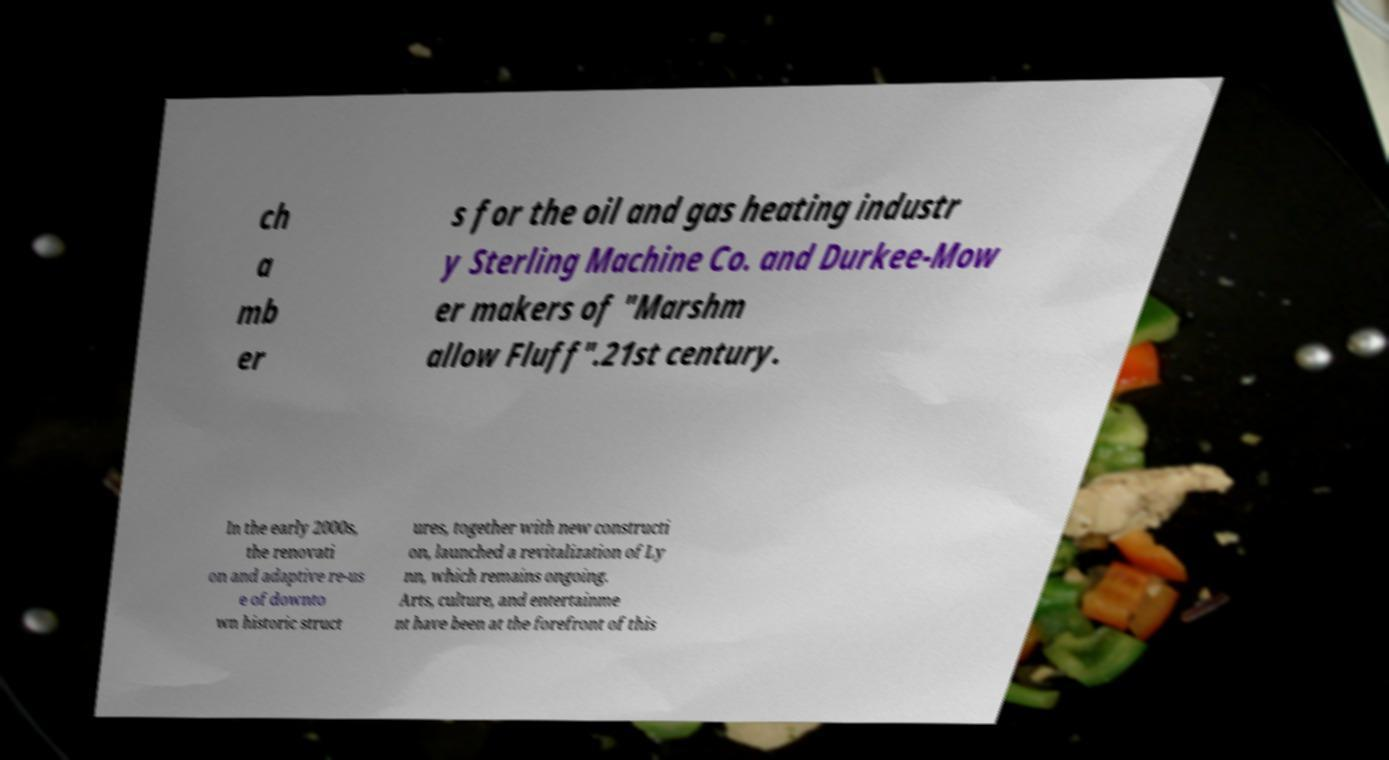Please read and relay the text visible in this image. What does it say? ch a mb er s for the oil and gas heating industr y Sterling Machine Co. and Durkee-Mow er makers of "Marshm allow Fluff".21st century. In the early 2000s, the renovati on and adaptive re-us e of downto wn historic struct ures, together with new constructi on, launched a revitalization of Ly nn, which remains ongoing. Arts, culture, and entertainme nt have been at the forefront of this 